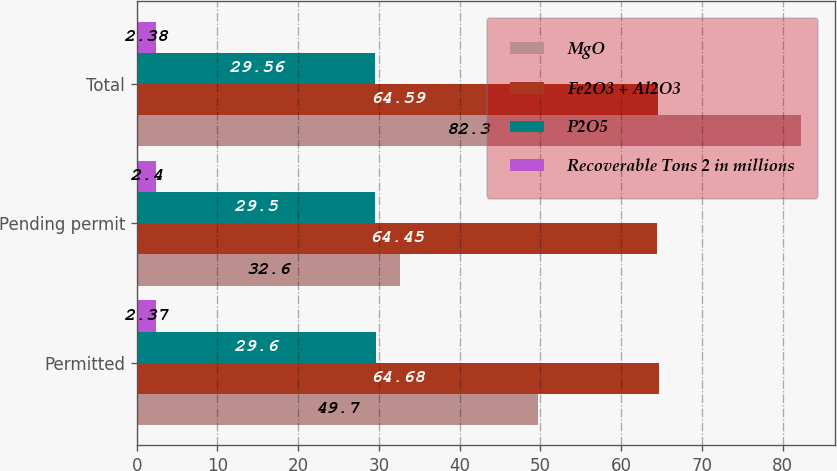Convert chart to OTSL. <chart><loc_0><loc_0><loc_500><loc_500><stacked_bar_chart><ecel><fcel>Permitted<fcel>Pending permit<fcel>Total<nl><fcel>MgO<fcel>49.7<fcel>32.6<fcel>82.3<nl><fcel>Fe2O3 + Al2O3<fcel>64.68<fcel>64.45<fcel>64.59<nl><fcel>P2O5<fcel>29.6<fcel>29.5<fcel>29.56<nl><fcel>Recoverable Tons 2 in millions<fcel>2.37<fcel>2.4<fcel>2.38<nl></chart> 